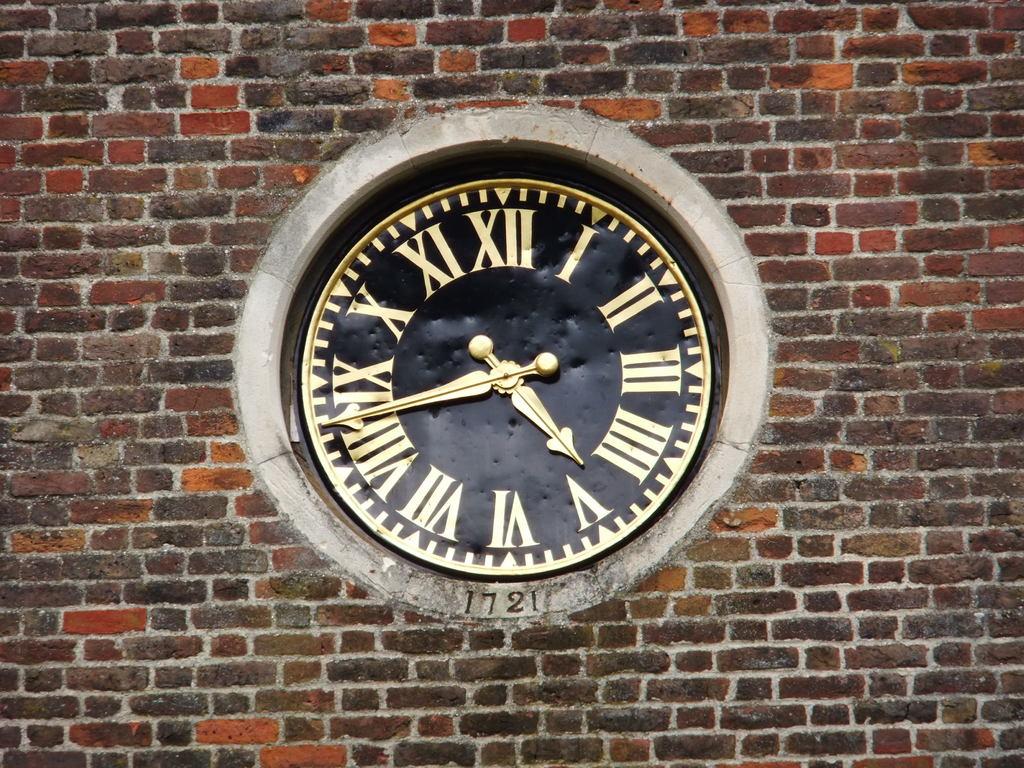What time is it?
Your answer should be very brief. 4:43. What number is on the clock?
Your answer should be compact. 1721. 